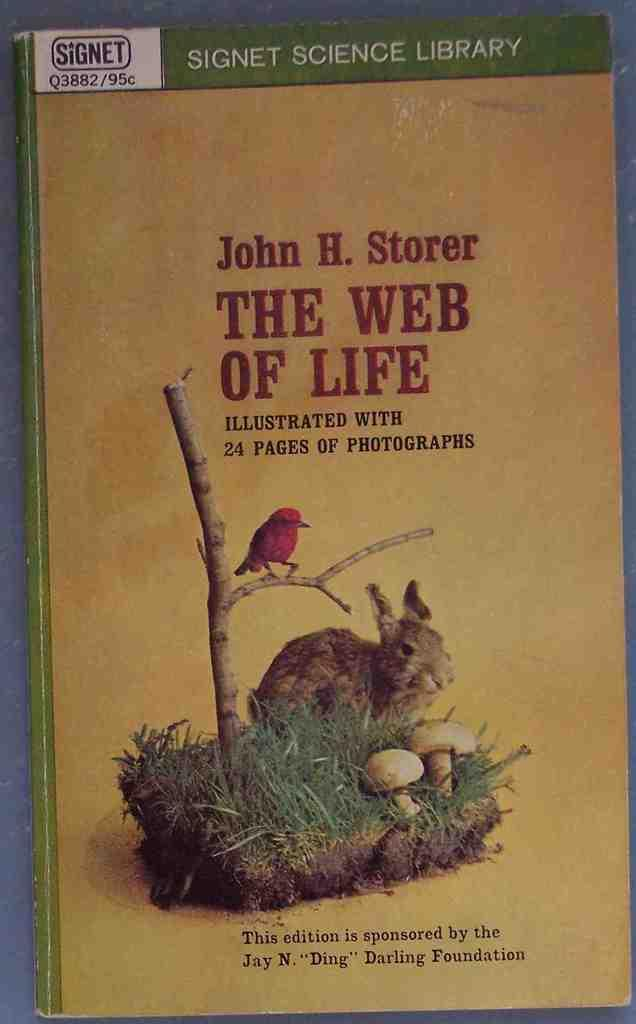What object can be seen in the picture? There is a book in the picture. What is featured on the cover of the book? The cover of the book has a photo. What animals and objects are depicted in the photo on the book cover? The photo on the book cover depicts a bird on a branch and a rabbit. It also includes mushrooms. What type of machine is shown in the photo on the book cover? There is no machine present in the photo on the book cover; it features a bird, a rabbit, and mushrooms. How many stalks of celery are visible in the photo on the book cover? There are no stalks of celery depicted in the photo on the book cover. 